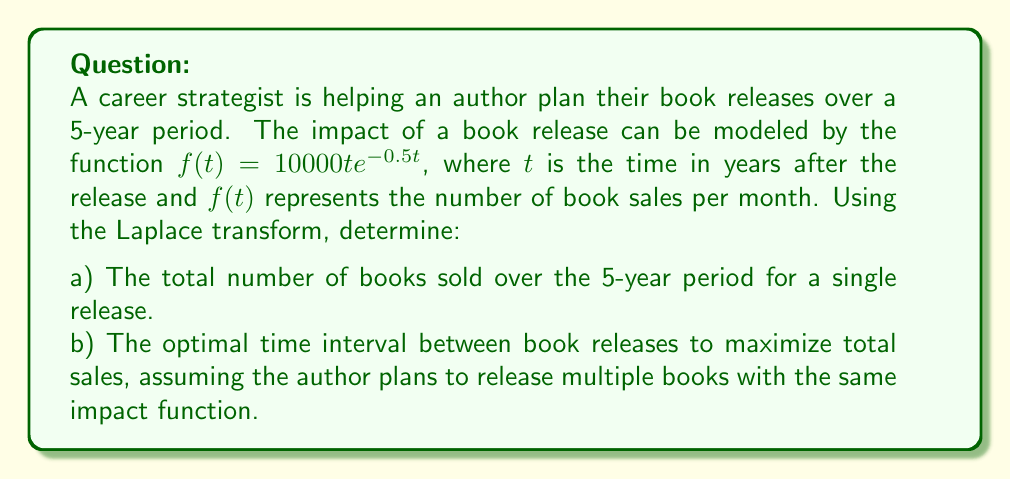Could you help me with this problem? Let's approach this problem step by step using Laplace transforms:

a) To find the total number of books sold over 5 years:

1. The Laplace transform of $f(t) = 10000te^{-0.5t}$ is:
   $$F(s) = \mathcal{L}\{10000te^{-0.5t}\} = \frac{10000}{(s+0.5)^2}$$

2. To find the total sales, we need to integrate $f(t)$ from 0 to 5. In the Laplace domain, this is equivalent to:
   $$\int_0^5 f(t) dt = \left.\frac{F(s)}{s}\right|_{s=0} - \left.\frac{F(s)}{s}e^{-5s}\right|_{s=0}$$

3. Evaluating this:
   $$\int_0^5 f(t) dt = \left.\frac{10000}{s(s+0.5)^2}\right|_{s=0} - \left.\frac{10000}{s(s+0.5)^2}e^{-5s}\right|_{s=0}$$
   $$= \frac{10000}{0.5^2} - \frac{10000}{0.5^2}e^{-5(0.5)} = 40000 - 40000e^{-2.5} \approx 33,729$$

b) For optimal time interval between releases:

1. The Laplace transform of a periodic function with period $T$ is:
   $$F_p(s) = \frac{F(s)}{1 - e^{-sT}}$$

2. The total impact over infinite time is given by:
   $$\lim_{s \to 0} sF_p(s) = \lim_{s \to 0} \frac{sF(s)}{1 - e^{-sT}}$$

3. Substituting our $F(s)$ and evaluating the limit:
   $$\lim_{s \to 0} \frac{10000s}{(s+0.5)^2(1 - e^{-sT})} = \frac{40000}{T}$$

4. To maximize this, we need to minimize $T$. However, practically, the author needs time between releases. A reasonable minimum time between releases might be 1 year.

Therefore, the optimal strategy would be to release a new book every year to maximize total sales impact.
Answer: a) Approximately 33,729 books sold over 5 years for a single release.
b) The optimal time interval between book releases is 1 year, assuming this is the minimum practical time between releases. 